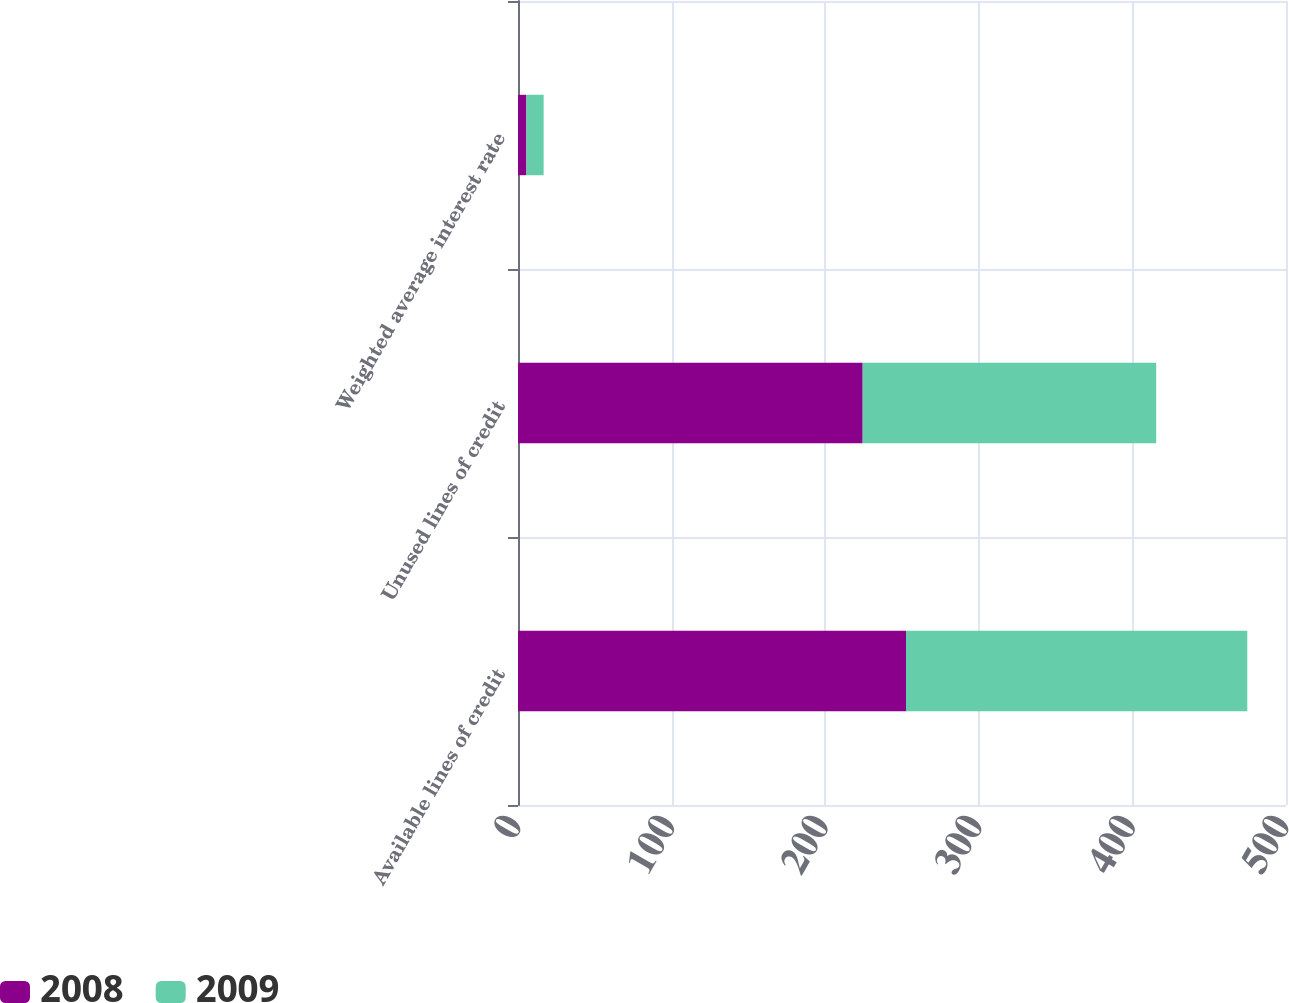Convert chart. <chart><loc_0><loc_0><loc_500><loc_500><stacked_bar_chart><ecel><fcel>Available lines of credit<fcel>Unused lines of credit<fcel>Weighted average interest rate<nl><fcel>2008<fcel>252.6<fcel>224.4<fcel>5.5<nl><fcel>2009<fcel>222.2<fcel>191.1<fcel>11.2<nl></chart> 